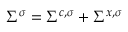Convert formula to latex. <formula><loc_0><loc_0><loc_500><loc_500>\Sigma ^ { \sigma } = \Sigma ^ { c , \sigma } + \Sigma ^ { x , \sigma }</formula> 